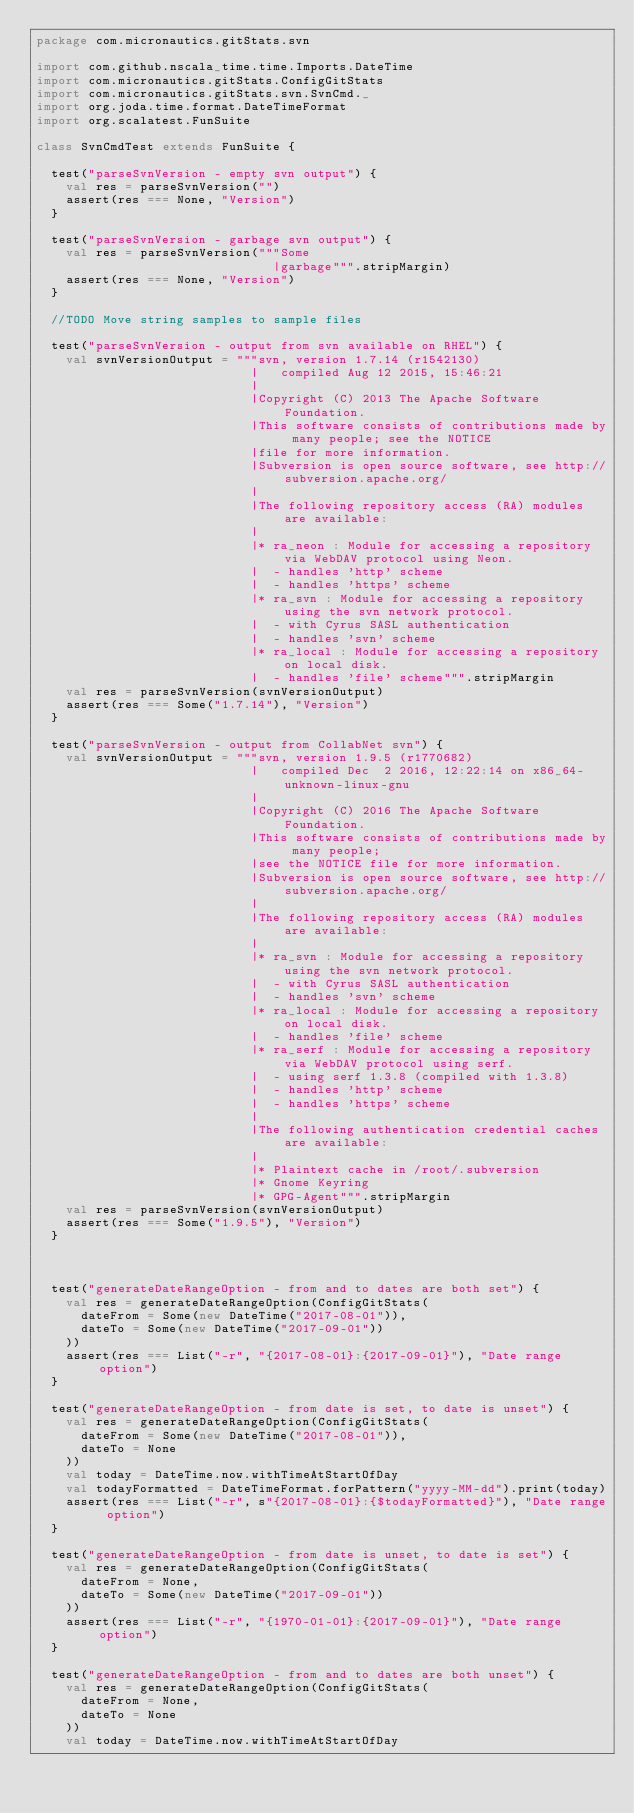<code> <loc_0><loc_0><loc_500><loc_500><_Scala_>package com.micronautics.gitStats.svn

import com.github.nscala_time.time.Imports.DateTime
import com.micronautics.gitStats.ConfigGitStats
import com.micronautics.gitStats.svn.SvnCmd._
import org.joda.time.format.DateTimeFormat
import org.scalatest.FunSuite

class SvnCmdTest extends FunSuite {

  test("parseSvnVersion - empty svn output") {
    val res = parseSvnVersion("")
    assert(res === None, "Version")
  }

  test("parseSvnVersion - garbage svn output") {
    val res = parseSvnVersion("""Some
                                |garbage""".stripMargin)
    assert(res === None, "Version")
  }

  //TODO Move string samples to sample files

  test("parseSvnVersion - output from svn available on RHEL") {
    val svnVersionOutput = """svn, version 1.7.14 (r1542130)
                             |   compiled Aug 12 2015, 15:46:21
                             |
                             |Copyright (C) 2013 The Apache Software Foundation.
                             |This software consists of contributions made by many people; see the NOTICE
                             |file for more information.
                             |Subversion is open source software, see http://subversion.apache.org/
                             |
                             |The following repository access (RA) modules are available:
                             |
                             |* ra_neon : Module for accessing a repository via WebDAV protocol using Neon.
                             |  - handles 'http' scheme
                             |  - handles 'https' scheme
                             |* ra_svn : Module for accessing a repository using the svn network protocol.
                             |  - with Cyrus SASL authentication
                             |  - handles 'svn' scheme
                             |* ra_local : Module for accessing a repository on local disk.
                             |  - handles 'file' scheme""".stripMargin
    val res = parseSvnVersion(svnVersionOutput)
    assert(res === Some("1.7.14"), "Version")
  }

  test("parseSvnVersion - output from CollabNet svn") {
    val svnVersionOutput = """svn, version 1.9.5 (r1770682)
                             |   compiled Dec  2 2016, 12:22:14 on x86_64-unknown-linux-gnu
                             |
                             |Copyright (C) 2016 The Apache Software Foundation.
                             |This software consists of contributions made by many people;
                             |see the NOTICE file for more information.
                             |Subversion is open source software, see http://subversion.apache.org/
                             |
                             |The following repository access (RA) modules are available:
                             |
                             |* ra_svn : Module for accessing a repository using the svn network protocol.
                             |  - with Cyrus SASL authentication
                             |  - handles 'svn' scheme
                             |* ra_local : Module for accessing a repository on local disk.
                             |  - handles 'file' scheme
                             |* ra_serf : Module for accessing a repository via WebDAV protocol using serf.
                             |  - using serf 1.3.8 (compiled with 1.3.8)
                             |  - handles 'http' scheme
                             |  - handles 'https' scheme
                             |
                             |The following authentication credential caches are available:
                             |
                             |* Plaintext cache in /root/.subversion
                             |* Gnome Keyring
                             |* GPG-Agent""".stripMargin
    val res = parseSvnVersion(svnVersionOutput)
    assert(res === Some("1.9.5"), "Version")
  }



  test("generateDateRangeOption - from and to dates are both set") {
    val res = generateDateRangeOption(ConfigGitStats(
      dateFrom = Some(new DateTime("2017-08-01")),
      dateTo = Some(new DateTime("2017-09-01"))
    ))
    assert(res === List("-r", "{2017-08-01}:{2017-09-01}"), "Date range option")
  }

  test("generateDateRangeOption - from date is set, to date is unset") {
    val res = generateDateRangeOption(ConfigGitStats(
      dateFrom = Some(new DateTime("2017-08-01")),
      dateTo = None
    ))
    val today = DateTime.now.withTimeAtStartOfDay
    val todayFormatted = DateTimeFormat.forPattern("yyyy-MM-dd").print(today)
    assert(res === List("-r", s"{2017-08-01}:{$todayFormatted}"), "Date range option")
  }

  test("generateDateRangeOption - from date is unset, to date is set") {
    val res = generateDateRangeOption(ConfigGitStats(
      dateFrom = None,
      dateTo = Some(new DateTime("2017-09-01"))
    ))
    assert(res === List("-r", "{1970-01-01}:{2017-09-01}"), "Date range option")
  }

  test("generateDateRangeOption - from and to dates are both unset") {
    val res = generateDateRangeOption(ConfigGitStats(
      dateFrom = None,
      dateTo = None
    ))
    val today = DateTime.now.withTimeAtStartOfDay</code> 